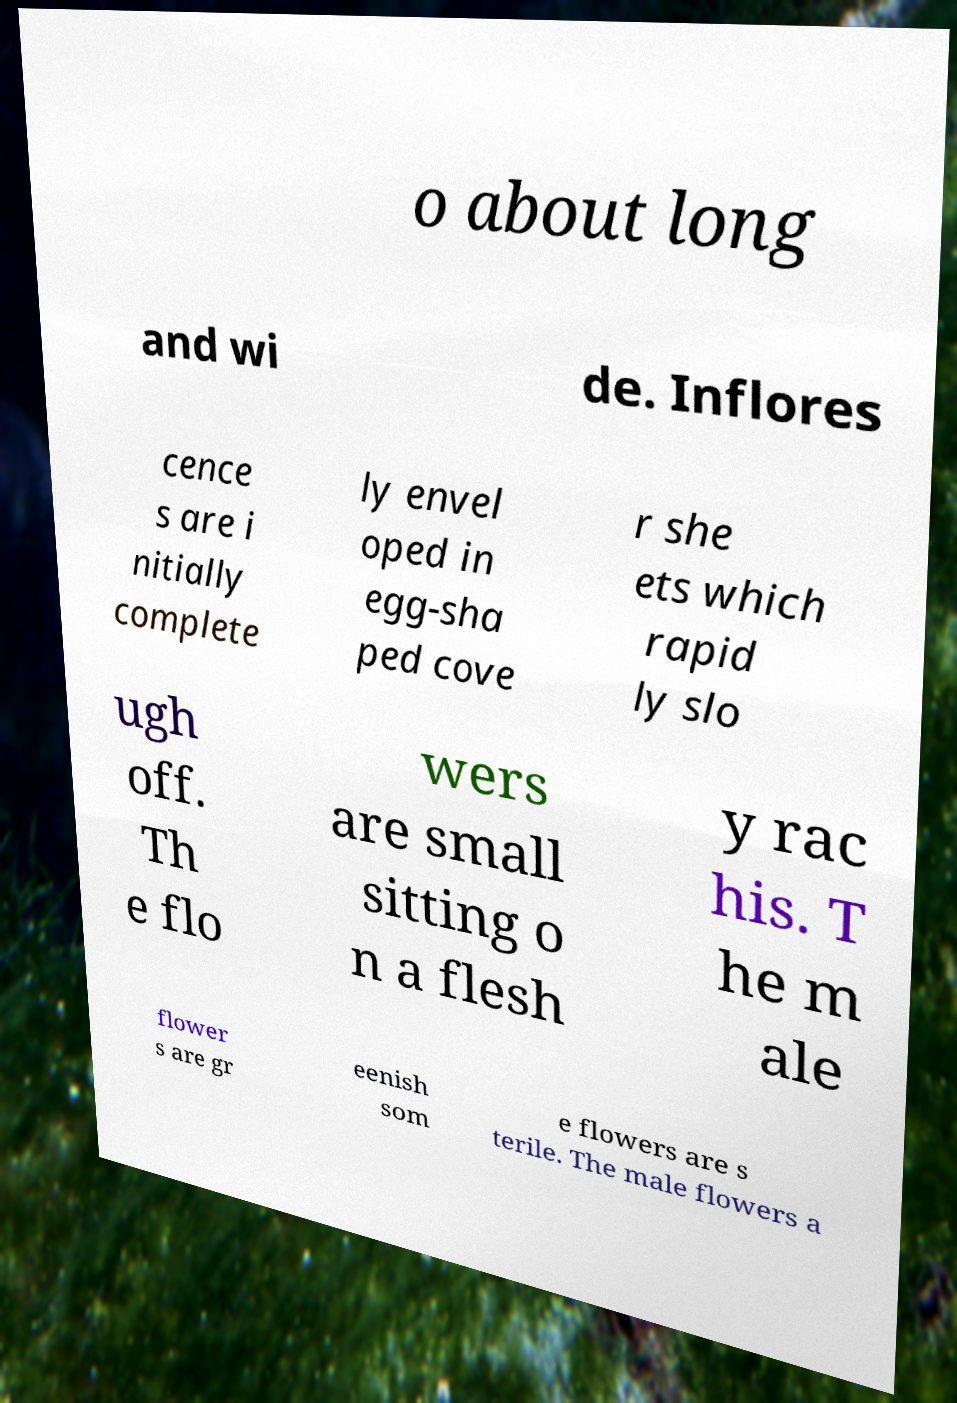There's text embedded in this image that I need extracted. Can you transcribe it verbatim? o about long and wi de. Inflores cence s are i nitially complete ly envel oped in egg-sha ped cove r she ets which rapid ly slo ugh off. Th e flo wers are small sitting o n a flesh y rac his. T he m ale flower s are gr eenish som e flowers are s terile. The male flowers a 